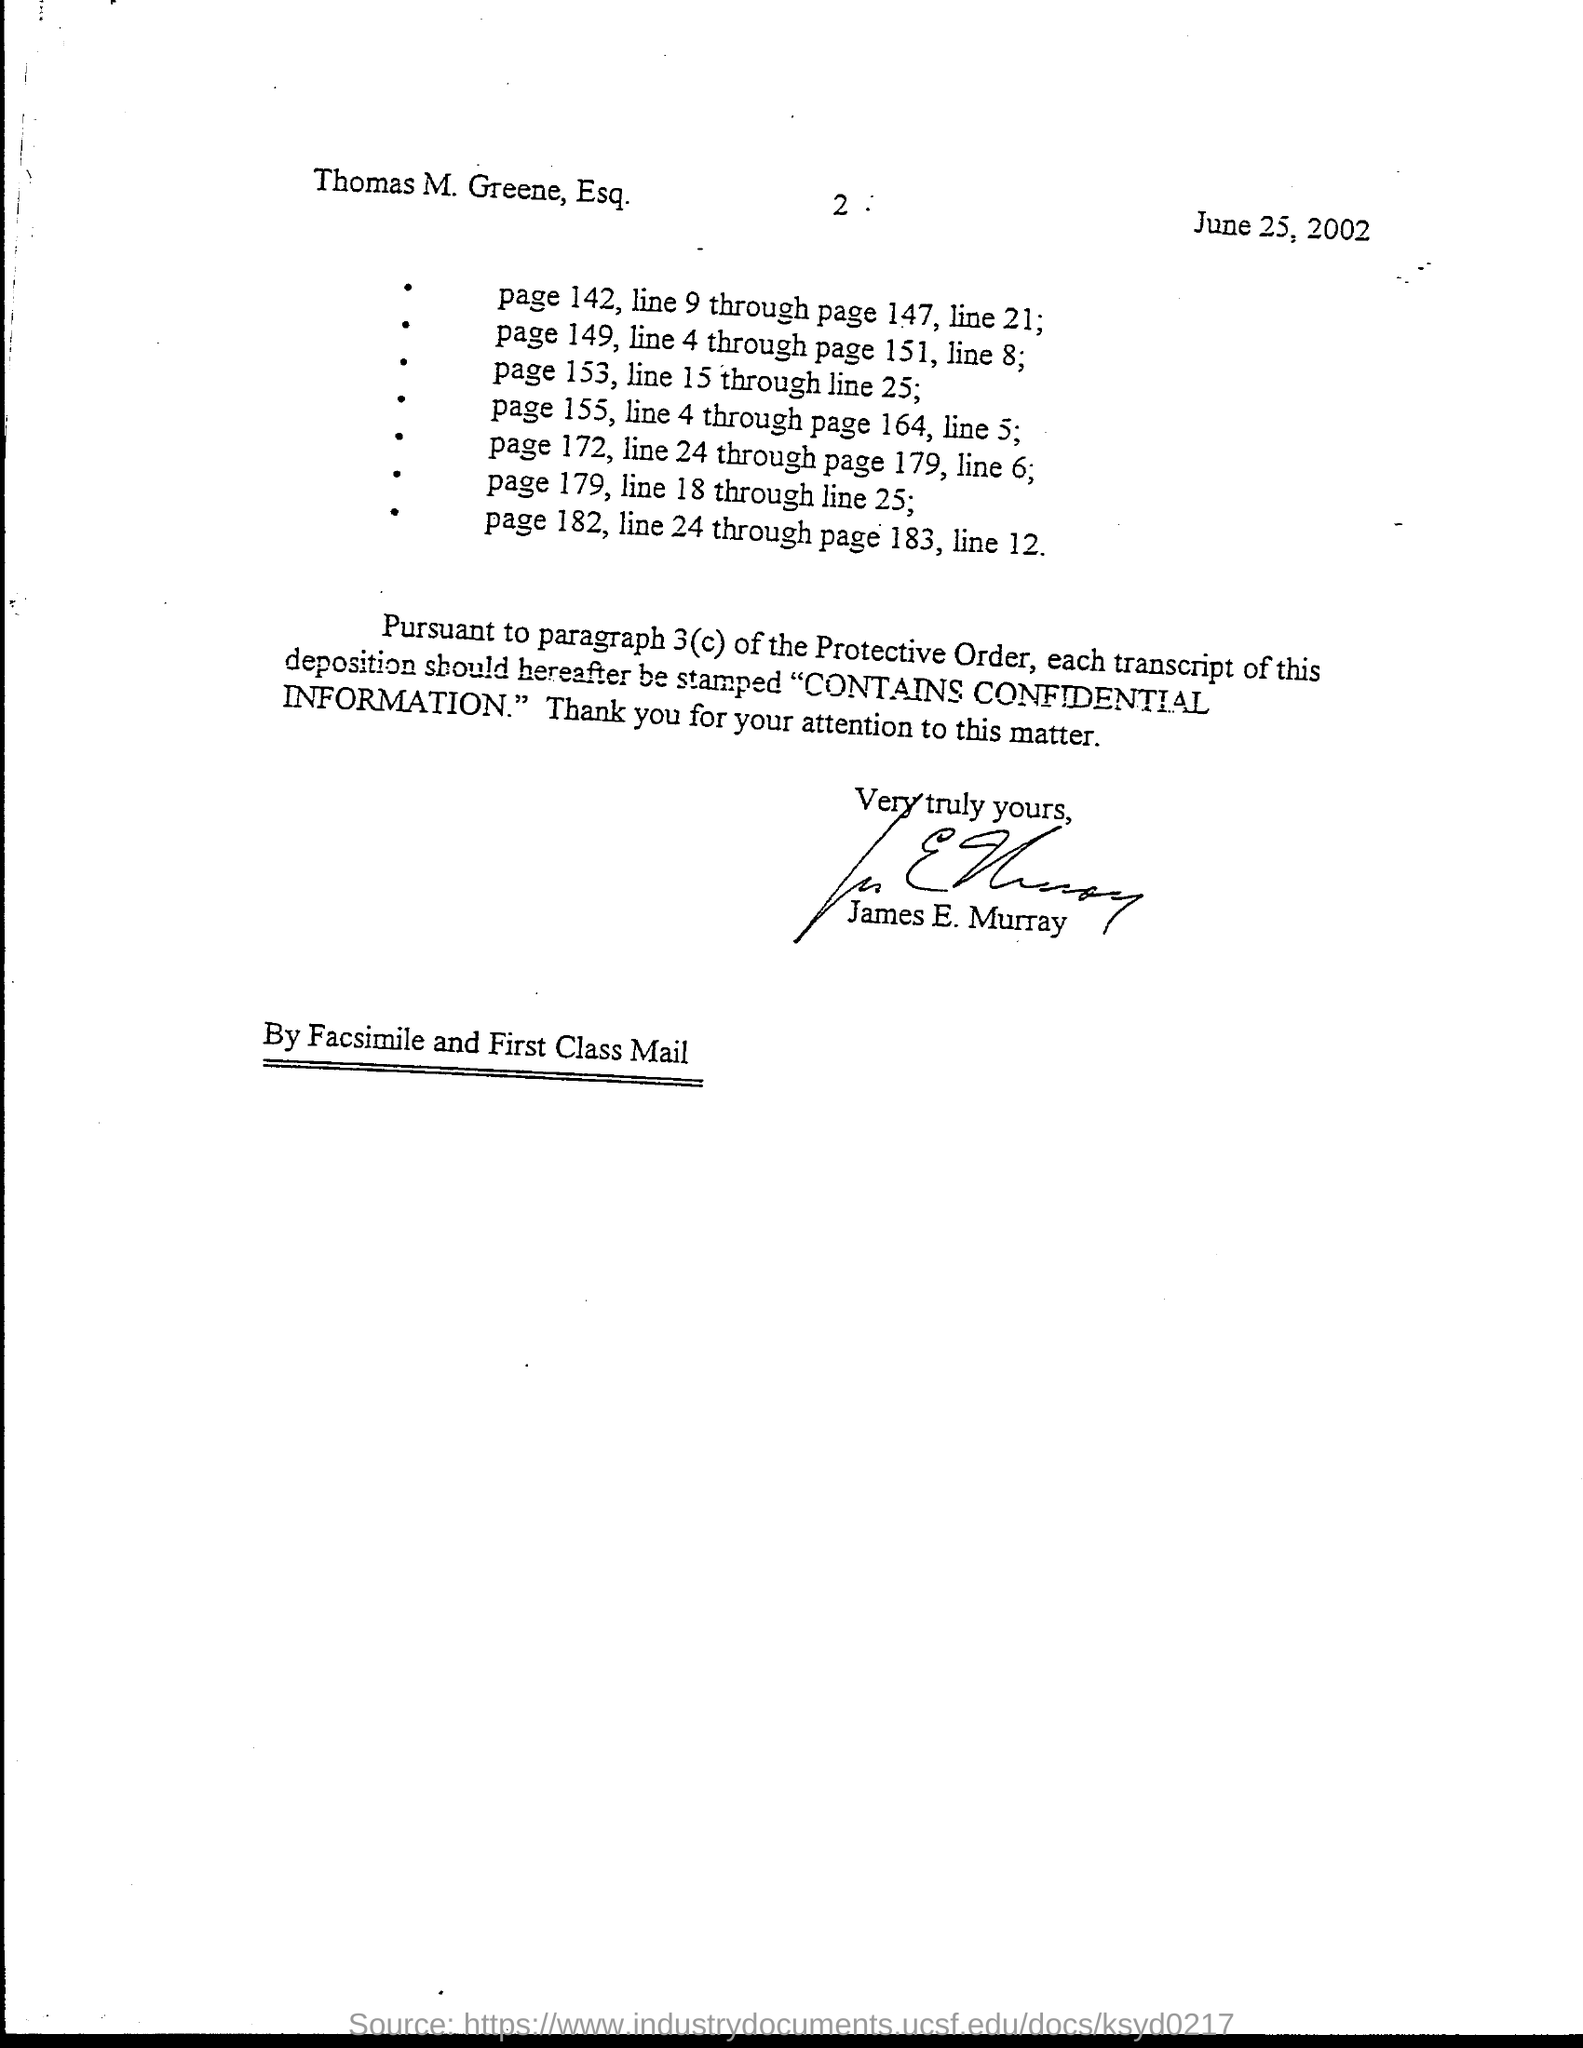What is the date mentioned in this document?
Make the answer very short. June 25, 2002. Who has signed this document?
Offer a very short reply. James E. Murray. 